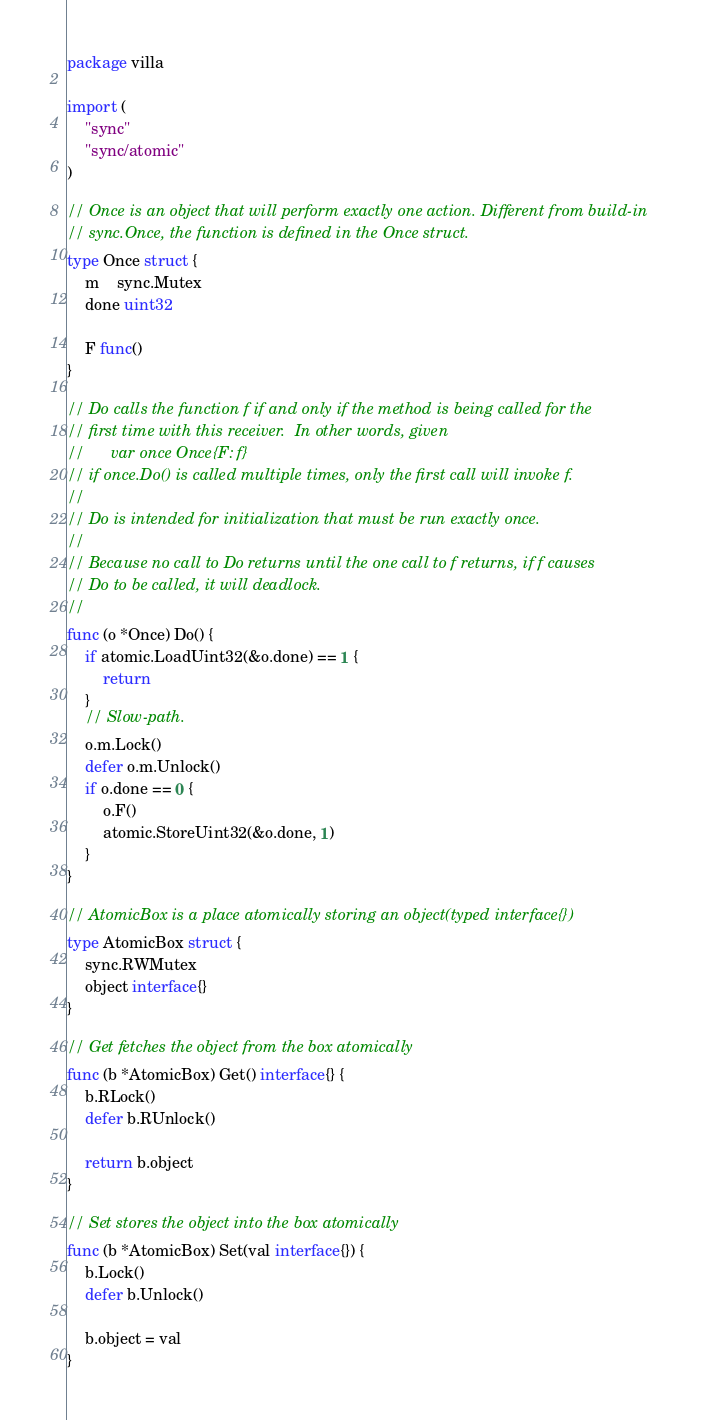<code> <loc_0><loc_0><loc_500><loc_500><_Go_>package villa

import (
	"sync"
	"sync/atomic"
)

// Once is an object that will perform exactly one action. Different from build-in
// sync.Once, the function is defined in the Once struct.
type Once struct {
	m    sync.Mutex
	done uint32

	F func()
}

// Do calls the function f if and only if the method is being called for the
// first time with this receiver.  In other words, given
//      var once Once{F: f}
// if once.Do() is called multiple times, only the first call will invoke f.
//
// Do is intended for initialization that must be run exactly once.
//
// Because no call to Do returns until the one call to f returns, if f causes
// Do to be called, it will deadlock.
//
func (o *Once) Do() {
	if atomic.LoadUint32(&o.done) == 1 {
		return
	}
	// Slow-path.
	o.m.Lock()
	defer o.m.Unlock()
	if o.done == 0 {
		o.F()
		atomic.StoreUint32(&o.done, 1)
	}
}

// AtomicBox is a place atomically storing an object(typed interface{})
type AtomicBox struct {
	sync.RWMutex
	object interface{}
}

// Get fetches the object from the box atomically
func (b *AtomicBox) Get() interface{} {
	b.RLock()
	defer b.RUnlock()

	return b.object
}

// Set stores the object into the box atomically
func (b *AtomicBox) Set(val interface{}) {
	b.Lock()
	defer b.Unlock()

	b.object = val
}
</code> 